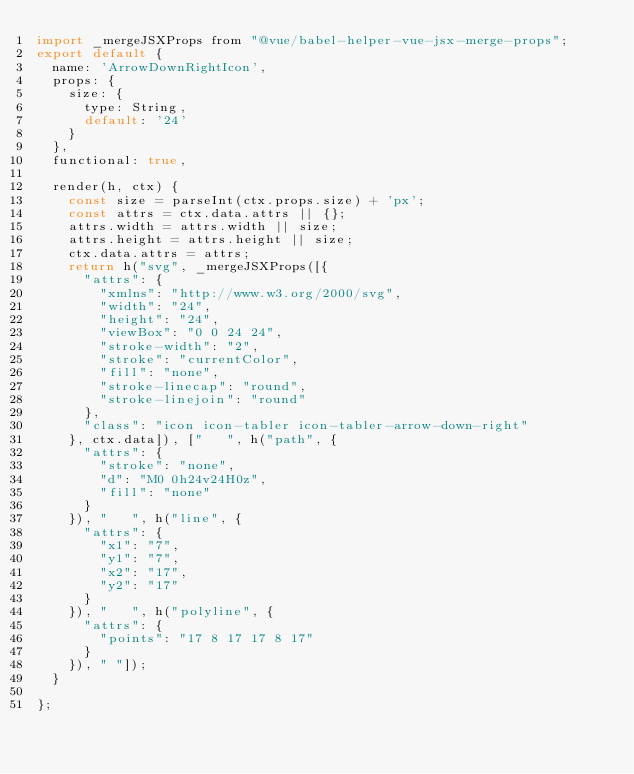Convert code to text. <code><loc_0><loc_0><loc_500><loc_500><_JavaScript_>import _mergeJSXProps from "@vue/babel-helper-vue-jsx-merge-props";
export default {
  name: 'ArrowDownRightIcon',
  props: {
    size: {
      type: String,
      default: '24'
    }
  },
  functional: true,

  render(h, ctx) {
    const size = parseInt(ctx.props.size) + 'px';
    const attrs = ctx.data.attrs || {};
    attrs.width = attrs.width || size;
    attrs.height = attrs.height || size;
    ctx.data.attrs = attrs;
    return h("svg", _mergeJSXProps([{
      "attrs": {
        "xmlns": "http://www.w3.org/2000/svg",
        "width": "24",
        "height": "24",
        "viewBox": "0 0 24 24",
        "stroke-width": "2",
        "stroke": "currentColor",
        "fill": "none",
        "stroke-linecap": "round",
        "stroke-linejoin": "round"
      },
      "class": "icon icon-tabler icon-tabler-arrow-down-right"
    }, ctx.data]), ["   ", h("path", {
      "attrs": {
        "stroke": "none",
        "d": "M0 0h24v24H0z",
        "fill": "none"
      }
    }), "   ", h("line", {
      "attrs": {
        "x1": "7",
        "y1": "7",
        "x2": "17",
        "y2": "17"
      }
    }), "   ", h("polyline", {
      "attrs": {
        "points": "17 8 17 17 8 17"
      }
    }), " "]);
  }

};</code> 